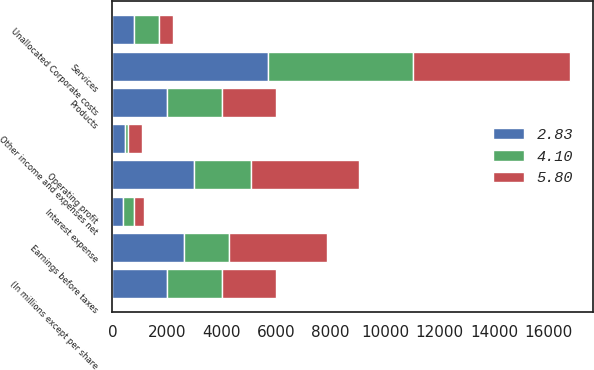Convert chart to OTSL. <chart><loc_0><loc_0><loc_500><loc_500><stacked_bar_chart><ecel><fcel>(In millions except per share<fcel>Products<fcel>Services<fcel>Unallocated Corporate costs<fcel>Other income and expenses net<fcel>Operating profit<fcel>Interest expense<fcel>Earnings before taxes<nl><fcel>5.8<fcel>2006<fcel>2004<fcel>5757<fcel>496<fcel>519<fcel>3953<fcel>361<fcel>3592<nl><fcel>2.83<fcel>2005<fcel>2004<fcel>5695<fcel>803<fcel>449<fcel>2986<fcel>370<fcel>2616<nl><fcel>4.1<fcel>2004<fcel>2004<fcel>5324<fcel>914<fcel>121<fcel>2089<fcel>425<fcel>1664<nl></chart> 